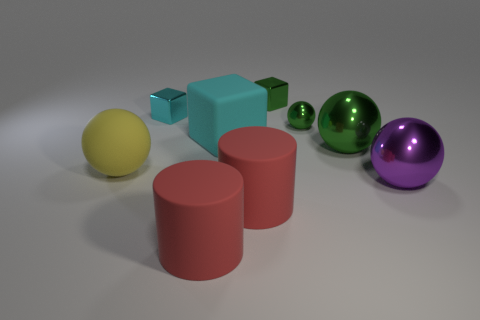Subtract all purple spheres. How many spheres are left? 3 Add 1 big yellow cubes. How many objects exist? 10 Subtract all balls. How many objects are left? 5 Subtract all big cyan cubes. Subtract all cyan blocks. How many objects are left? 6 Add 2 big balls. How many big balls are left? 5 Add 1 small rubber cubes. How many small rubber cubes exist? 1 Subtract 0 gray blocks. How many objects are left? 9 